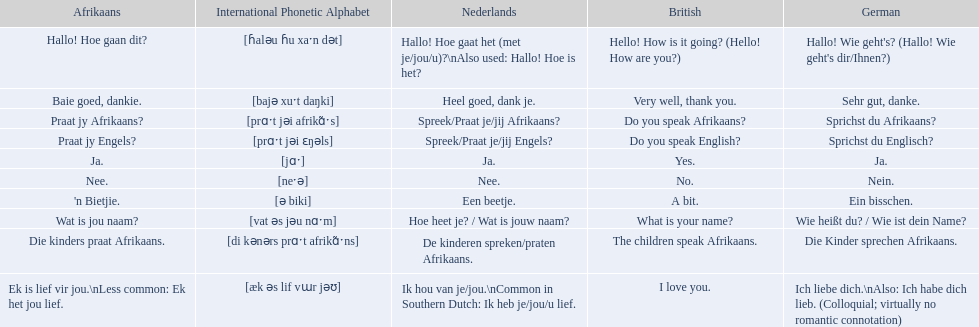What are the afrikaans phrases? Hallo! Hoe gaan dit?, Baie goed, dankie., Praat jy Afrikaans?, Praat jy Engels?, Ja., Nee., 'n Bietjie., Wat is jou naam?, Die kinders praat Afrikaans., Ek is lief vir jou.\nLess common: Ek het jou lief. For die kinders praat afrikaans, what are the translations? De kinderen spreken/praten Afrikaans., The children speak Afrikaans., Die Kinder sprechen Afrikaans. Which one is the german translation? Die Kinder sprechen Afrikaans. Could you parse the entire table? {'header': ['Afrikaans', 'International Phonetic Alphabet', 'Nederlands', 'British', 'German'], 'rows': [['Hallo! Hoe gaan dit?', '[ɦaləu ɦu xaˑn dət]', 'Hallo! Hoe gaat het (met je/jou/u)?\\nAlso used: Hallo! Hoe is het?', 'Hello! How is it going? (Hello! How are you?)', "Hallo! Wie geht's? (Hallo! Wie geht's dir/Ihnen?)"], ['Baie goed, dankie.', '[bajə xuˑt daŋki]', 'Heel goed, dank je.', 'Very well, thank you.', 'Sehr gut, danke.'], ['Praat jy Afrikaans?', '[prɑˑt jəi afrikɑ̃ˑs]', 'Spreek/Praat je/jij Afrikaans?', 'Do you speak Afrikaans?', 'Sprichst du Afrikaans?'], ['Praat jy Engels?', '[prɑˑt jəi ɛŋəls]', 'Spreek/Praat je/jij Engels?', 'Do you speak English?', 'Sprichst du Englisch?'], ['Ja.', '[jɑˑ]', 'Ja.', 'Yes.', 'Ja.'], ['Nee.', '[neˑə]', 'Nee.', 'No.', 'Nein.'], ["'n Bietjie.", '[ə biki]', 'Een beetje.', 'A bit.', 'Ein bisschen.'], ['Wat is jou naam?', '[vat əs jəu nɑˑm]', 'Hoe heet je? / Wat is jouw naam?', 'What is your name?', 'Wie heißt du? / Wie ist dein Name?'], ['Die kinders praat Afrikaans.', '[di kənərs prɑˑt afrikɑ̃ˑns]', 'De kinderen spreken/praten Afrikaans.', 'The children speak Afrikaans.', 'Die Kinder sprechen Afrikaans.'], ['Ek is lief vir jou.\\nLess common: Ek het jou lief.', '[æk əs lif vɯr jəʊ]', 'Ik hou van je/jou.\\nCommon in Southern Dutch: Ik heb je/jou/u lief.', 'I love you.', 'Ich liebe dich.\\nAlso: Ich habe dich lieb. (Colloquial; virtually no romantic connotation)']]} 